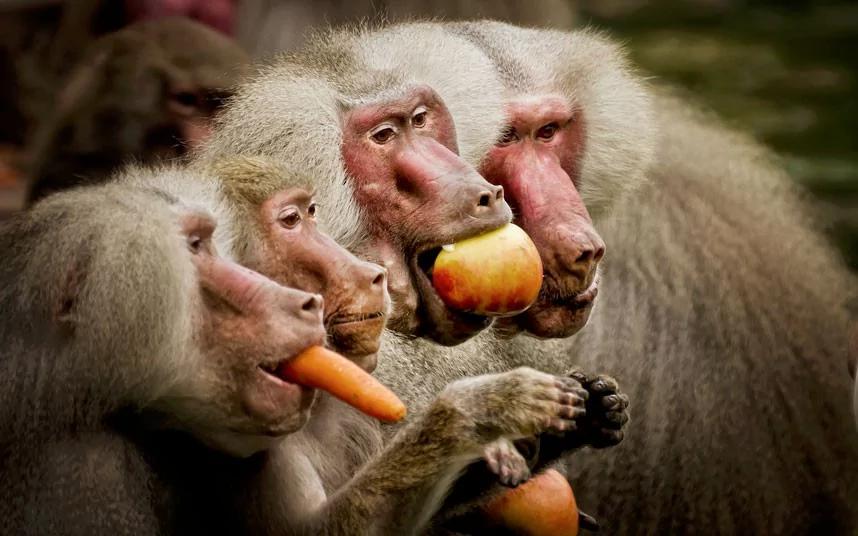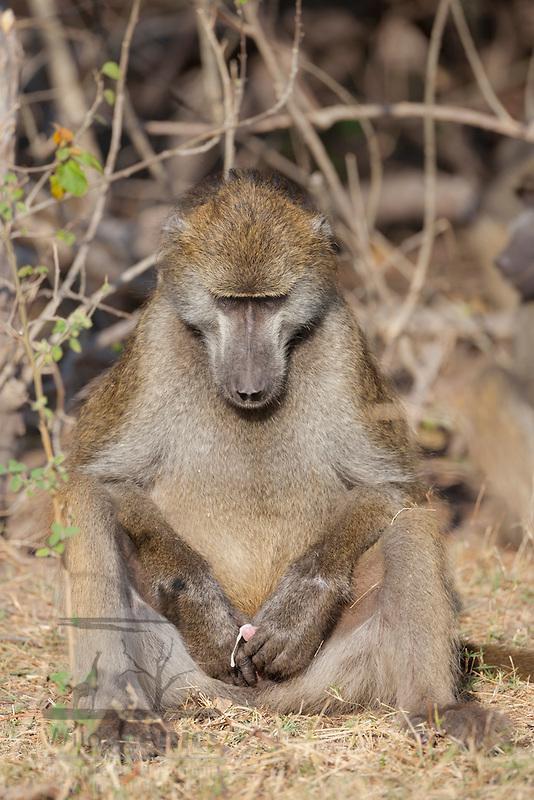The first image is the image on the left, the second image is the image on the right. Analyze the images presented: Is the assertion "One image shows at least three baboons posed close together, and the other image shows one forward-facing baboon sitting with bent knees." valid? Answer yes or no. Yes. The first image is the image on the left, the second image is the image on the right. Examine the images to the left and right. Is the description "The monkey in the right image is eating something." accurate? Answer yes or no. No. 